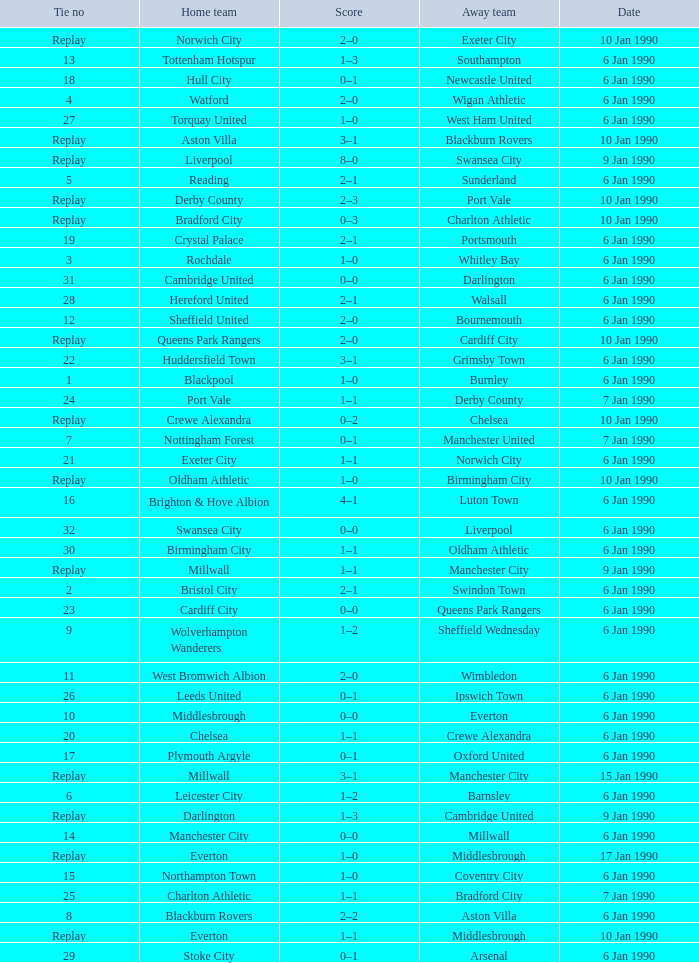What was the score of the game against away team crewe alexandra? 1–1. Give me the full table as a dictionary. {'header': ['Tie no', 'Home team', 'Score', 'Away team', 'Date'], 'rows': [['Replay', 'Norwich City', '2–0', 'Exeter City', '10 Jan 1990'], ['13', 'Tottenham Hotspur', '1–3', 'Southampton', '6 Jan 1990'], ['18', 'Hull City', '0–1', 'Newcastle United', '6 Jan 1990'], ['4', 'Watford', '2–0', 'Wigan Athletic', '6 Jan 1990'], ['27', 'Torquay United', '1–0', 'West Ham United', '6 Jan 1990'], ['Replay', 'Aston Villa', '3–1', 'Blackburn Rovers', '10 Jan 1990'], ['Replay', 'Liverpool', '8–0', 'Swansea City', '9 Jan 1990'], ['5', 'Reading', '2–1', 'Sunderland', '6 Jan 1990'], ['Replay', 'Derby County', '2–3', 'Port Vale', '10 Jan 1990'], ['Replay', 'Bradford City', '0–3', 'Charlton Athletic', '10 Jan 1990'], ['19', 'Crystal Palace', '2–1', 'Portsmouth', '6 Jan 1990'], ['3', 'Rochdale', '1–0', 'Whitley Bay', '6 Jan 1990'], ['31', 'Cambridge United', '0–0', 'Darlington', '6 Jan 1990'], ['28', 'Hereford United', '2–1', 'Walsall', '6 Jan 1990'], ['12', 'Sheffield United', '2–0', 'Bournemouth', '6 Jan 1990'], ['Replay', 'Queens Park Rangers', '2–0', 'Cardiff City', '10 Jan 1990'], ['22', 'Huddersfield Town', '3–1', 'Grimsby Town', '6 Jan 1990'], ['1', 'Blackpool', '1–0', 'Burnley', '6 Jan 1990'], ['24', 'Port Vale', '1–1', 'Derby County', '7 Jan 1990'], ['Replay', 'Crewe Alexandra', '0–2', 'Chelsea', '10 Jan 1990'], ['7', 'Nottingham Forest', '0–1', 'Manchester United', '7 Jan 1990'], ['21', 'Exeter City', '1–1', 'Norwich City', '6 Jan 1990'], ['Replay', 'Oldham Athletic', '1–0', 'Birmingham City', '10 Jan 1990'], ['16', 'Brighton & Hove Albion', '4–1', 'Luton Town', '6 Jan 1990'], ['32', 'Swansea City', '0–0', 'Liverpool', '6 Jan 1990'], ['30', 'Birmingham City', '1–1', 'Oldham Athletic', '6 Jan 1990'], ['Replay', 'Millwall', '1–1', 'Manchester City', '9 Jan 1990'], ['2', 'Bristol City', '2–1', 'Swindon Town', '6 Jan 1990'], ['23', 'Cardiff City', '0–0', 'Queens Park Rangers', '6 Jan 1990'], ['9', 'Wolverhampton Wanderers', '1–2', 'Sheffield Wednesday', '6 Jan 1990'], ['11', 'West Bromwich Albion', '2–0', 'Wimbledon', '6 Jan 1990'], ['26', 'Leeds United', '0–1', 'Ipswich Town', '6 Jan 1990'], ['10', 'Middlesbrough', '0–0', 'Everton', '6 Jan 1990'], ['20', 'Chelsea', '1–1', 'Crewe Alexandra', '6 Jan 1990'], ['17', 'Plymouth Argyle', '0–1', 'Oxford United', '6 Jan 1990'], ['Replay', 'Millwall', '3–1', 'Manchester City', '15 Jan 1990'], ['6', 'Leicester City', '1–2', 'Barnsley', '6 Jan 1990'], ['Replay', 'Darlington', '1–3', 'Cambridge United', '9 Jan 1990'], ['14', 'Manchester City', '0–0', 'Millwall', '6 Jan 1990'], ['Replay', 'Everton', '1–0', 'Middlesbrough', '17 Jan 1990'], ['15', 'Northampton Town', '1–0', 'Coventry City', '6 Jan 1990'], ['25', 'Charlton Athletic', '1–1', 'Bradford City', '7 Jan 1990'], ['8', 'Blackburn Rovers', '2–2', 'Aston Villa', '6 Jan 1990'], ['Replay', 'Everton', '1–1', 'Middlesbrough', '10 Jan 1990'], ['29', 'Stoke City', '0–1', 'Arsenal', '6 Jan 1990']]} 